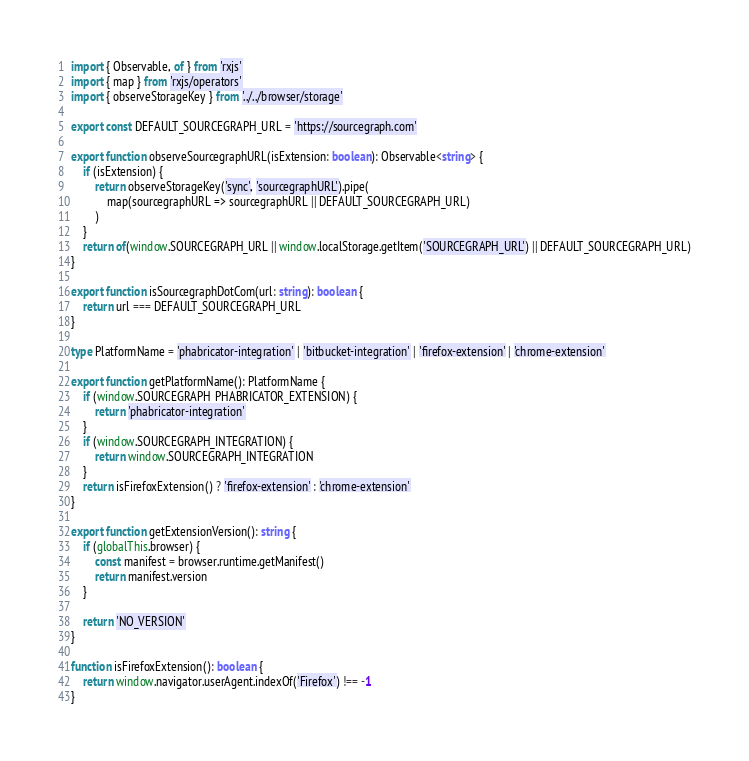<code> <loc_0><loc_0><loc_500><loc_500><_TypeScript_>import { Observable, of } from 'rxjs'
import { map } from 'rxjs/operators'
import { observeStorageKey } from '../../browser/storage'

export const DEFAULT_SOURCEGRAPH_URL = 'https://sourcegraph.com'

export function observeSourcegraphURL(isExtension: boolean): Observable<string> {
    if (isExtension) {
        return observeStorageKey('sync', 'sourcegraphURL').pipe(
            map(sourcegraphURL => sourcegraphURL || DEFAULT_SOURCEGRAPH_URL)
        )
    }
    return of(window.SOURCEGRAPH_URL || window.localStorage.getItem('SOURCEGRAPH_URL') || DEFAULT_SOURCEGRAPH_URL)
}

export function isSourcegraphDotCom(url: string): boolean {
    return url === DEFAULT_SOURCEGRAPH_URL
}

type PlatformName = 'phabricator-integration' | 'bitbucket-integration' | 'firefox-extension' | 'chrome-extension'

export function getPlatformName(): PlatformName {
    if (window.SOURCEGRAPH_PHABRICATOR_EXTENSION) {
        return 'phabricator-integration'
    }
    if (window.SOURCEGRAPH_INTEGRATION) {
        return window.SOURCEGRAPH_INTEGRATION
    }
    return isFirefoxExtension() ? 'firefox-extension' : 'chrome-extension'
}

export function getExtensionVersion(): string {
    if (globalThis.browser) {
        const manifest = browser.runtime.getManifest()
        return manifest.version
    }

    return 'NO_VERSION'
}

function isFirefoxExtension(): boolean {
    return window.navigator.userAgent.indexOf('Firefox') !== -1
}
</code> 